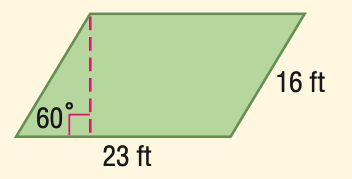Answer the mathemtical geometry problem and directly provide the correct option letter.
Question: Find the area of the parallelogram.
Choices: A: 184 B: 260.2 C: 318.7 D: 368 C 